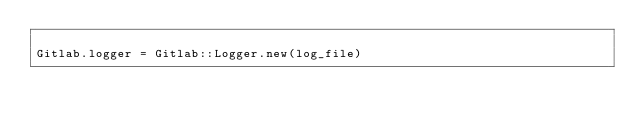Convert code to text. <code><loc_0><loc_0><loc_500><loc_500><_Crystal_>
Gitlab.logger = Gitlab::Logger.new(log_file)
</code> 